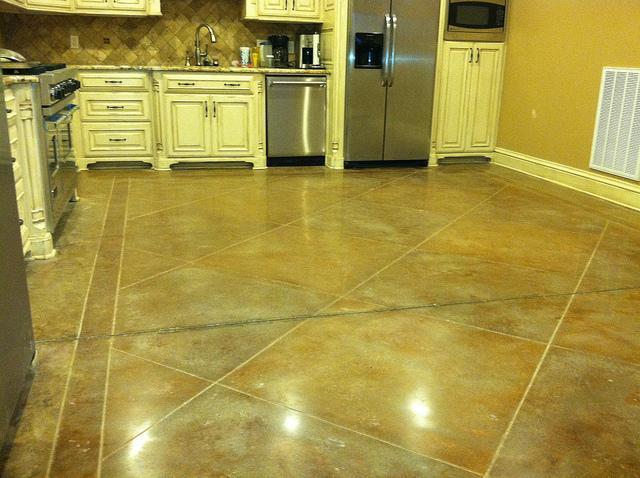How many lights are reflected on the floor?
Give a very brief answer. 3. How many ovens are visible?
Give a very brief answer. 1. How many umbrellas with yellow stripes are on the beach?
Give a very brief answer. 0. 